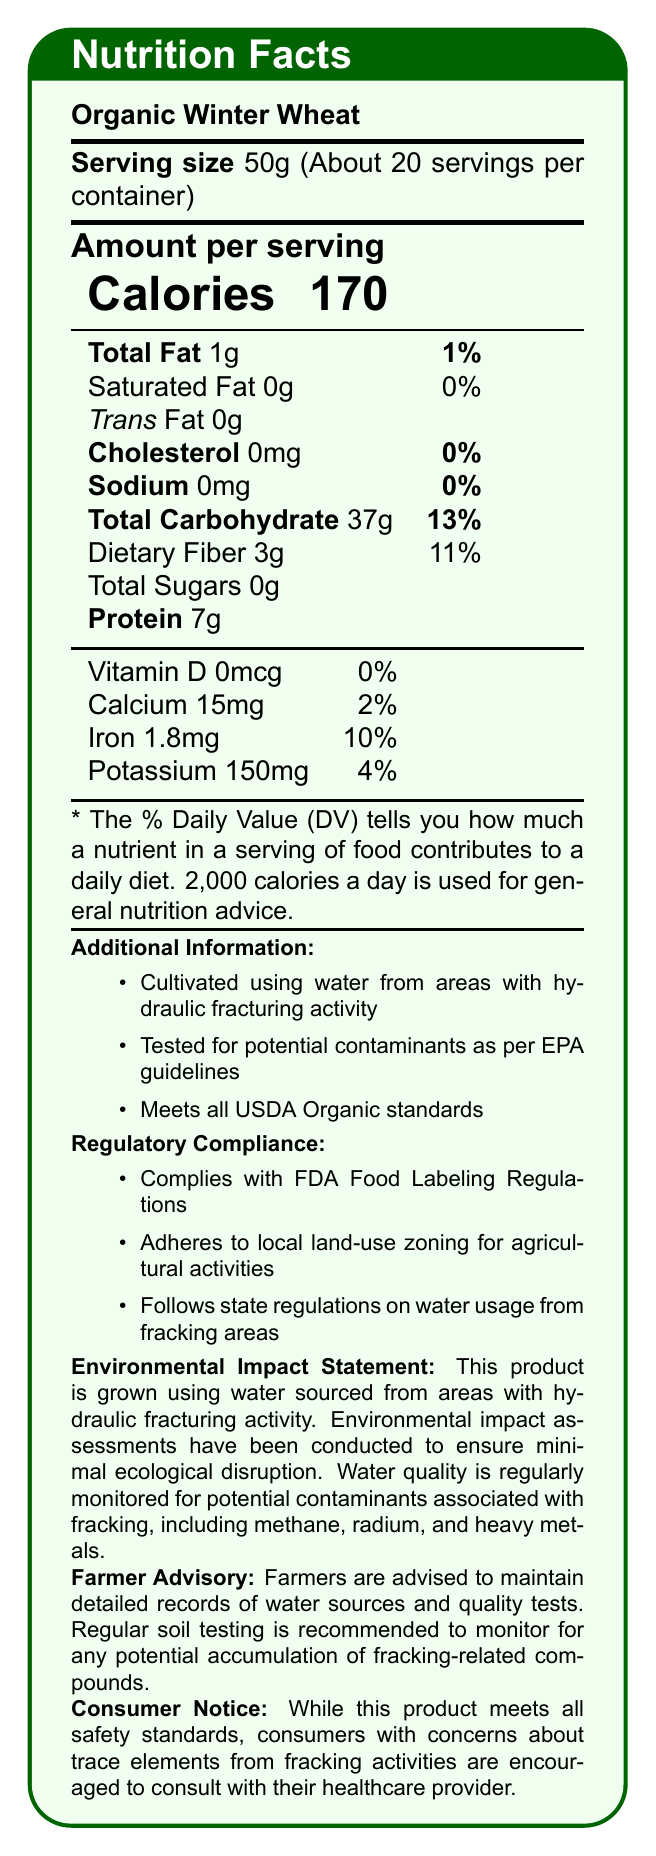what is the product name? The product name is mentioned at the top of the document as "Organic Winter Wheat".
Answer: Organic Winter Wheat what is the serving size? The serving size is specified as "50g" in the document.
Answer: 50g how many calories are there per serving? The document states that each serving contains "170 calories".
Answer: 170 what percentage of the daily value is the total fat? The percentage of the daily value for total fat is given as "1%" in the document.
Answer: 1% how much protein is in one serving? The document lists the protein content as "7g".
Answer: 7g What potential contaminants are monitored in this product? A. Bacteria, Pesticides B. Methane, Radium C. Heavy Metals, Microplastics D. Pesticides, Nitrites The document mentions that water is monitored for potential contaminants from fracking, including "methane, radium, and heavy metals".
Answer: B Which regulatory compliance does this product satisfy? A. ISO 9001 B. USDA Organic standards C. EU agricultural standards D. Codex Alimentarius The document states that the product "meets all USDA Organic standards" under additional information.
Answer: B Does the product comply with the FDA Food Labeling Regulations? Under regulatory compliance, it is mentioned that the product "complies with FDA Food Labeling Regulations".
Answer: Yes Are there any sugars present in the product? The document specifies that total sugars are "0g".
Answer: No Please summarize the main idea of the document. The document's main idea is to present the nutritional information and safety assurances of Organic Winter Wheat, cultivated using water from fracking areas, tested for contaminants, and compliant with various regulations.
Answer: The document provides the nutrition facts for Organic Winter Wheat, including serving size, calories, various nutrient levels, and additional information about its cultivation using water from hydraulic fracturing areas. It also includes regulatory compliance details and an environmental impact statement. What is the serving size for children under 5 years? The document does not provide any specific serving size information for children under 5 years.
Answer: Not enough information 